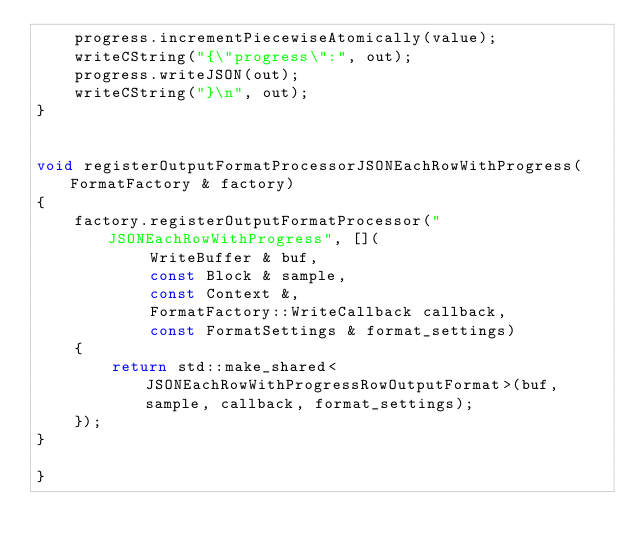Convert code to text. <code><loc_0><loc_0><loc_500><loc_500><_C++_>    progress.incrementPiecewiseAtomically(value);
    writeCString("{\"progress\":", out);
    progress.writeJSON(out);
    writeCString("}\n", out);
}


void registerOutputFormatProcessorJSONEachRowWithProgress(FormatFactory & factory)
{
    factory.registerOutputFormatProcessor("JSONEachRowWithProgress", [](
            WriteBuffer & buf,
            const Block & sample,
            const Context &,
            FormatFactory::WriteCallback callback,
            const FormatSettings & format_settings)
    {
        return std::make_shared<JSONEachRowWithProgressRowOutputFormat>(buf, sample, callback, format_settings);
    });
}

}
</code> 